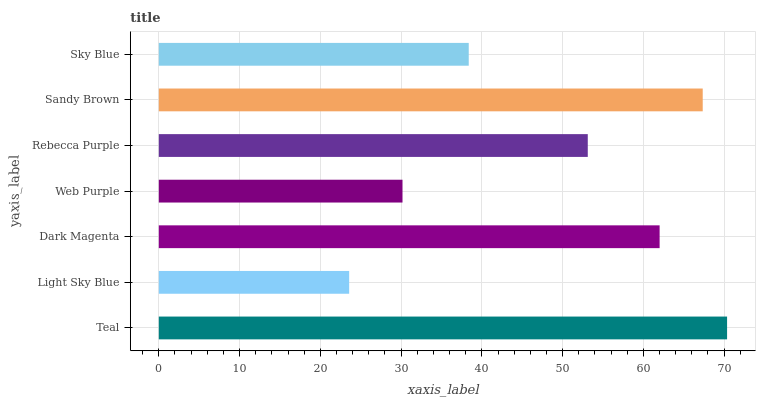Is Light Sky Blue the minimum?
Answer yes or no. Yes. Is Teal the maximum?
Answer yes or no. Yes. Is Dark Magenta the minimum?
Answer yes or no. No. Is Dark Magenta the maximum?
Answer yes or no. No. Is Dark Magenta greater than Light Sky Blue?
Answer yes or no. Yes. Is Light Sky Blue less than Dark Magenta?
Answer yes or no. Yes. Is Light Sky Blue greater than Dark Magenta?
Answer yes or no. No. Is Dark Magenta less than Light Sky Blue?
Answer yes or no. No. Is Rebecca Purple the high median?
Answer yes or no. Yes. Is Rebecca Purple the low median?
Answer yes or no. Yes. Is Sandy Brown the high median?
Answer yes or no. No. Is Web Purple the low median?
Answer yes or no. No. 